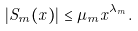<formula> <loc_0><loc_0><loc_500><loc_500>| S _ { m } ( x ) | \leq \mu _ { m } x ^ { \lambda _ { m } } .</formula> 